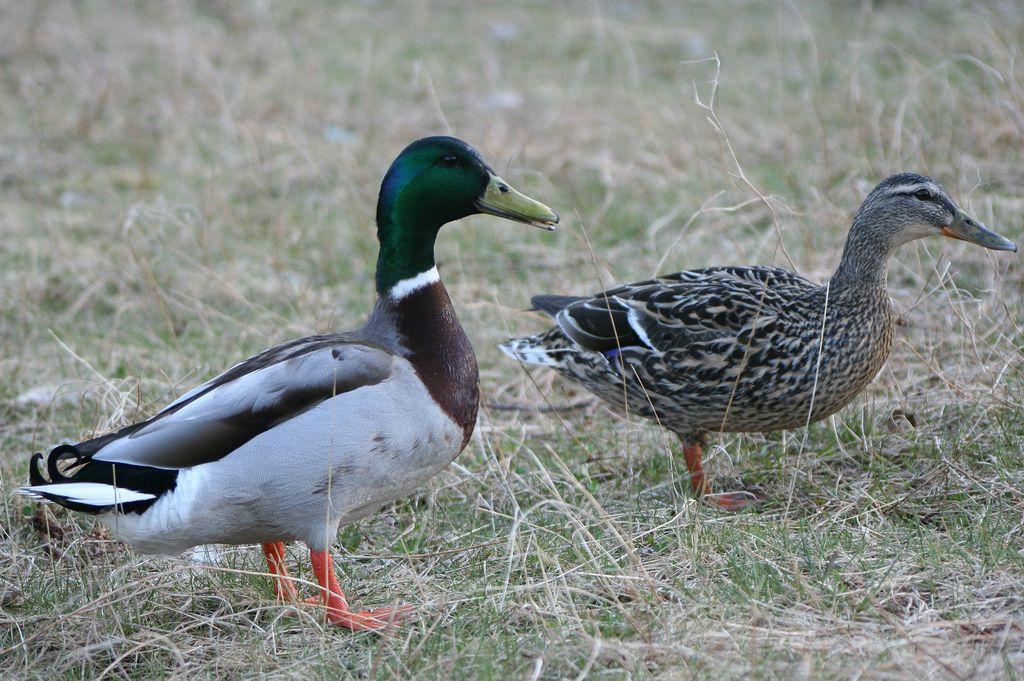Could you give a brief overview of what you see in this image? In this picture there are two ducks on the grassland in the image. 